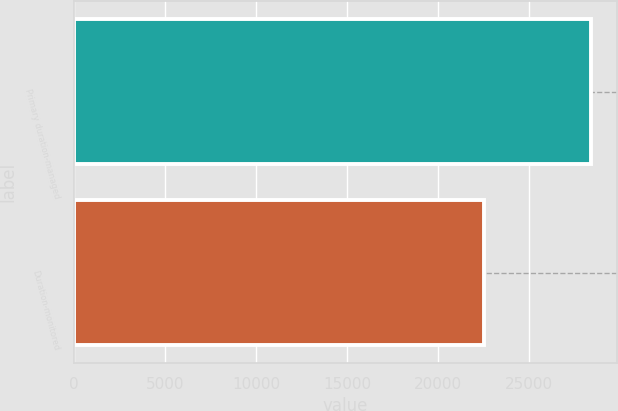Convert chart. <chart><loc_0><loc_0><loc_500><loc_500><bar_chart><fcel>Primary duration-managed<fcel>Duration-monitored<nl><fcel>28377.1<fcel>22497.1<nl></chart> 